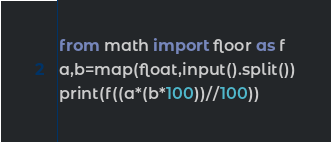Convert code to text. <code><loc_0><loc_0><loc_500><loc_500><_Python_>from math import floor as f
a,b=map(float,input().split())
print(f((a*(b*100))//100))</code> 